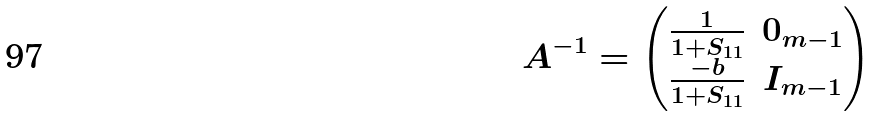Convert formula to latex. <formula><loc_0><loc_0><loc_500><loc_500>A ^ { - 1 } = \begin{pmatrix} \frac { 1 } { 1 + S _ { 1 1 } } & 0 _ { m - 1 } \\ \frac { - b } { 1 + S _ { 1 1 } } & I _ { m - 1 } \end{pmatrix}</formula> 